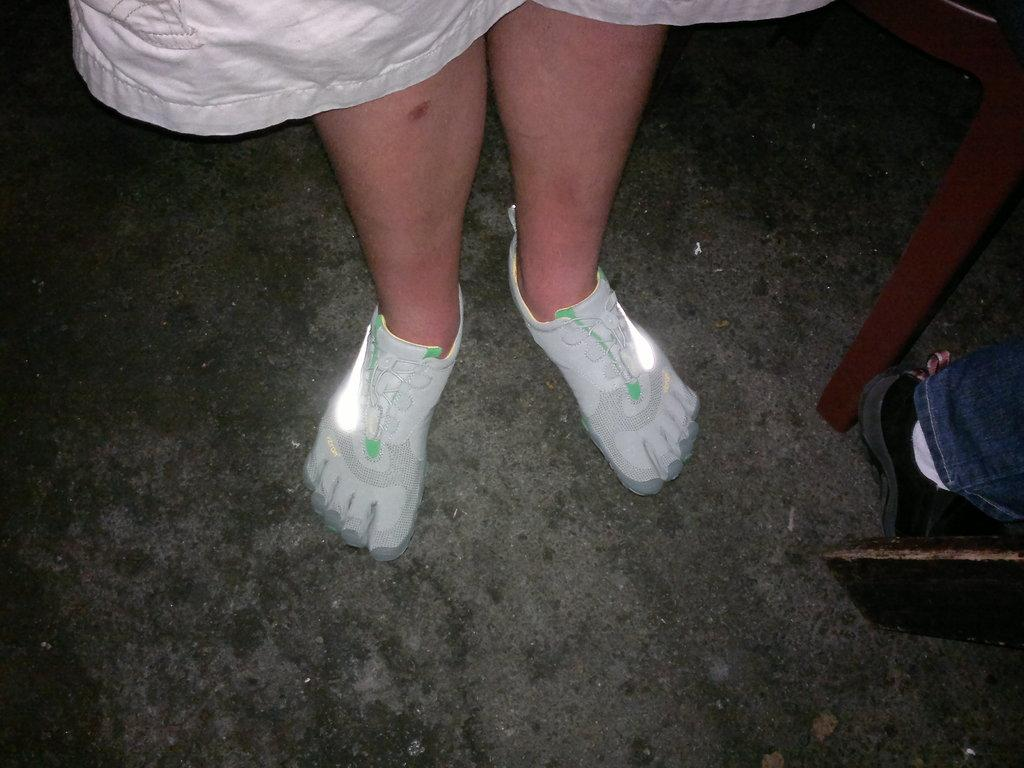What can be seen in the image related to a person? There is a person in the image, and their legs are visible. What are the person's legs wearing? The person's legs are wearing shoes. What is unique about the shoes? The shoes have lights on them. Are there any other people in the image? Yes, there is another person in the image. What can be said about the second person's shoes? The second person is wearing shoes. What type of boats can be seen in the image? There are no boats present in the image. What kind of waste is being disposed of in the image? There is no waste disposal activity depicted in the image. 